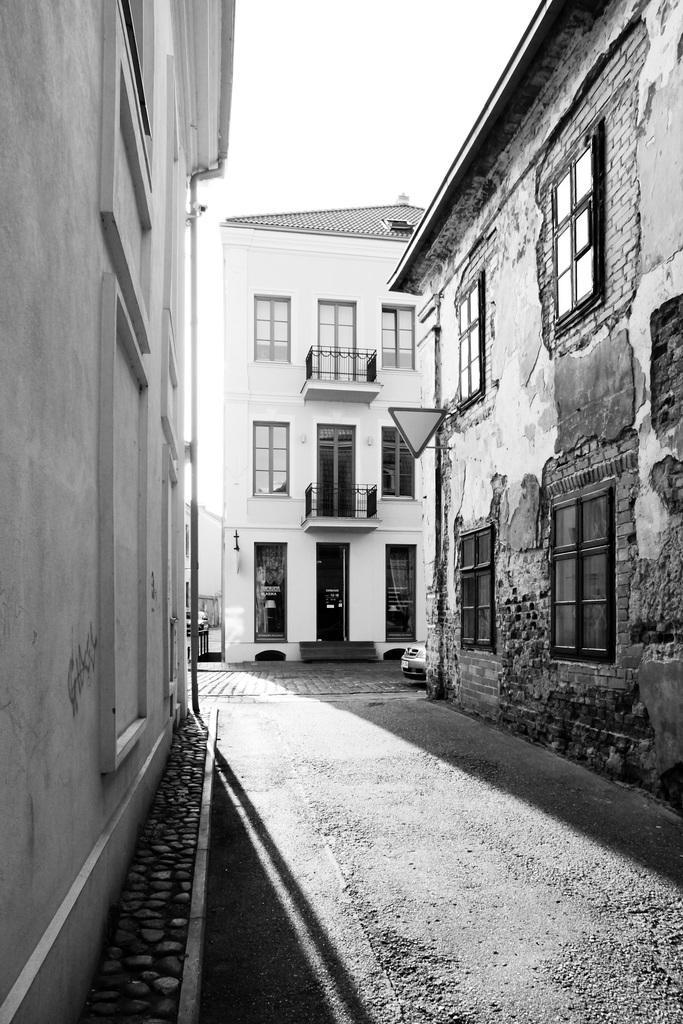Could you give a brief overview of what you see in this image? This is a black and white image. At the bottom there is a road. In the background, I can see the buildings. At the top of the image I can see sky. 